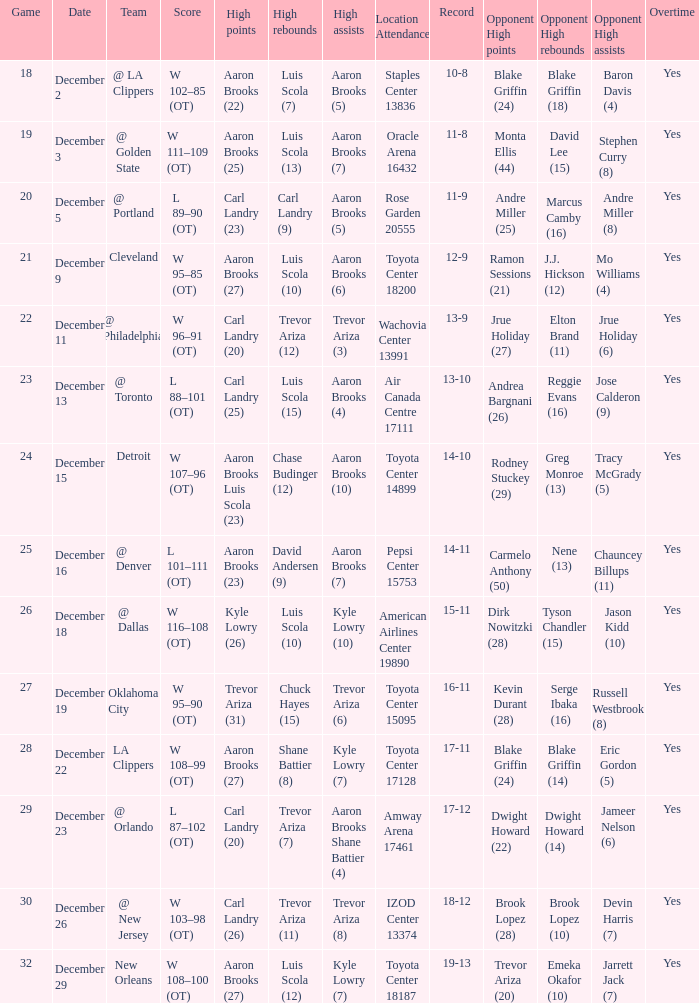Where was the game in which Carl Landry (25) did the most high points played? Air Canada Centre 17111. 